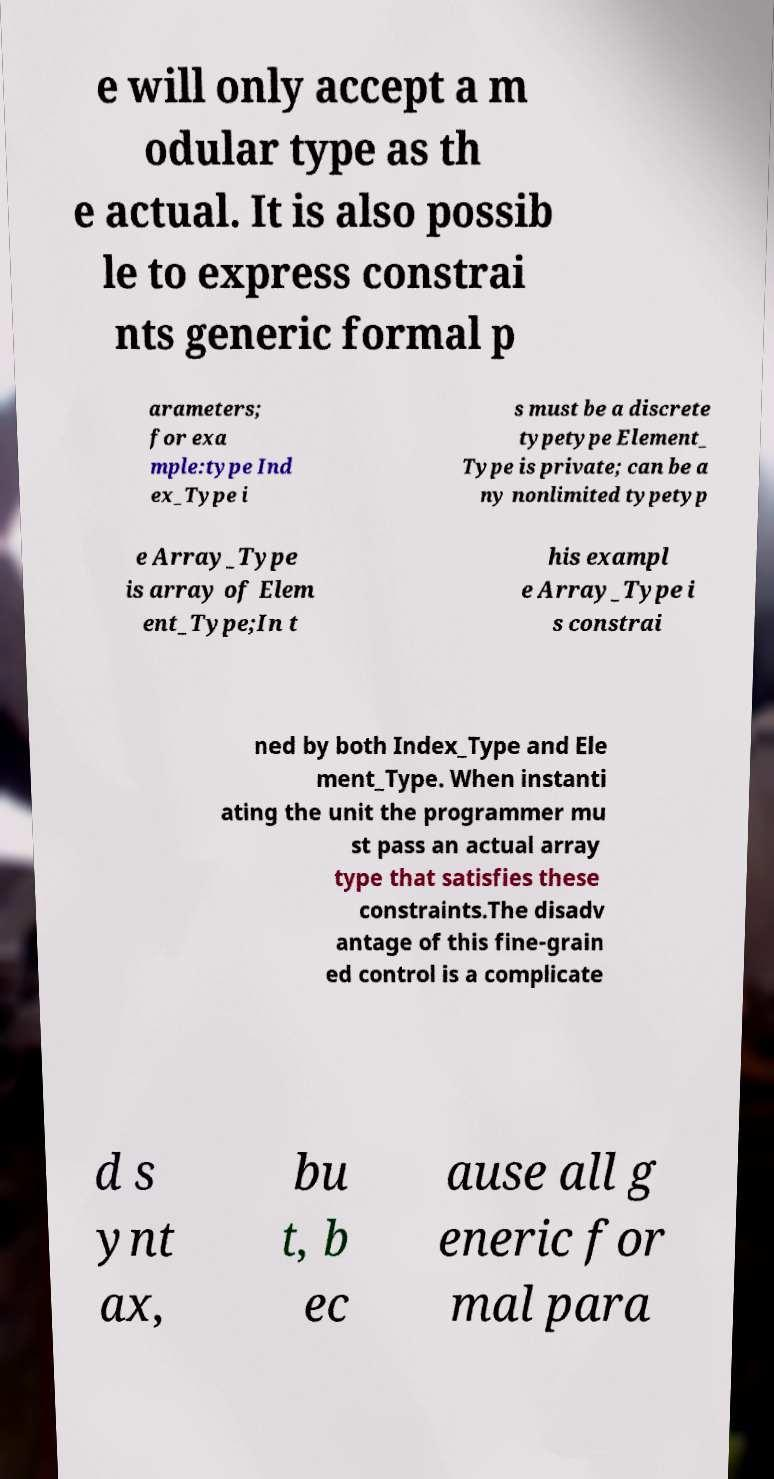Can you read and provide the text displayed in the image?This photo seems to have some interesting text. Can you extract and type it out for me? e will only accept a m odular type as th e actual. It is also possib le to express constrai nts generic formal p arameters; for exa mple:type Ind ex_Type i s must be a discrete typetype Element_ Type is private; can be a ny nonlimited typetyp e Array_Type is array of Elem ent_Type;In t his exampl e Array_Type i s constrai ned by both Index_Type and Ele ment_Type. When instanti ating the unit the programmer mu st pass an actual array type that satisfies these constraints.The disadv antage of this fine-grain ed control is a complicate d s ynt ax, bu t, b ec ause all g eneric for mal para 